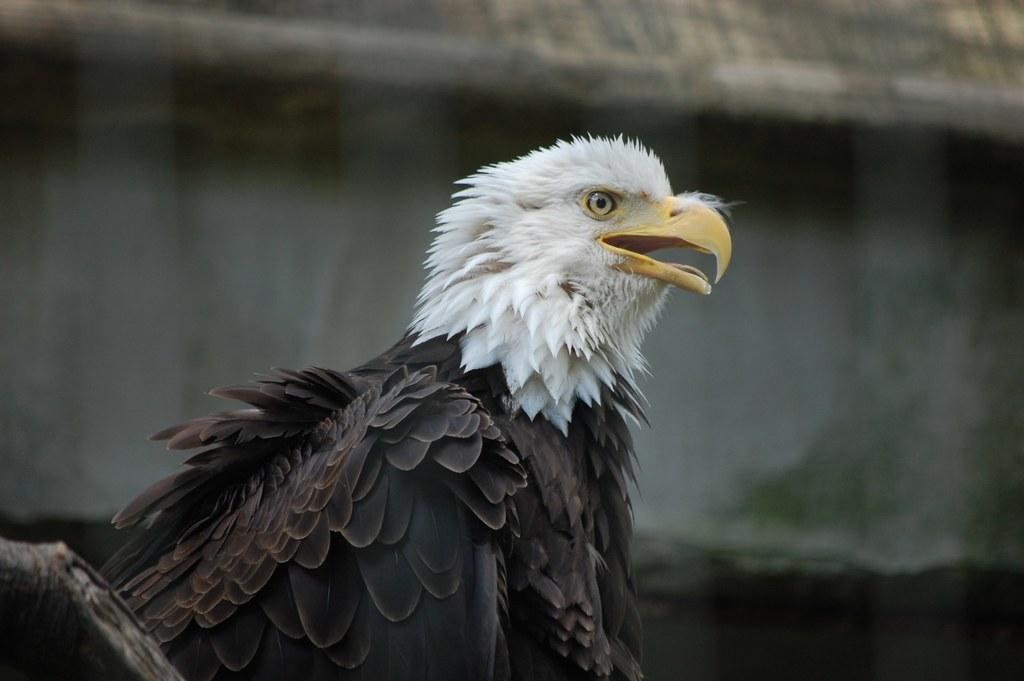Can you describe this image briefly? In this image, I can see an eagle, which is white and brown in color. These are the feathers. I can see a beak, which is yellow in color. The background looks blurry. 